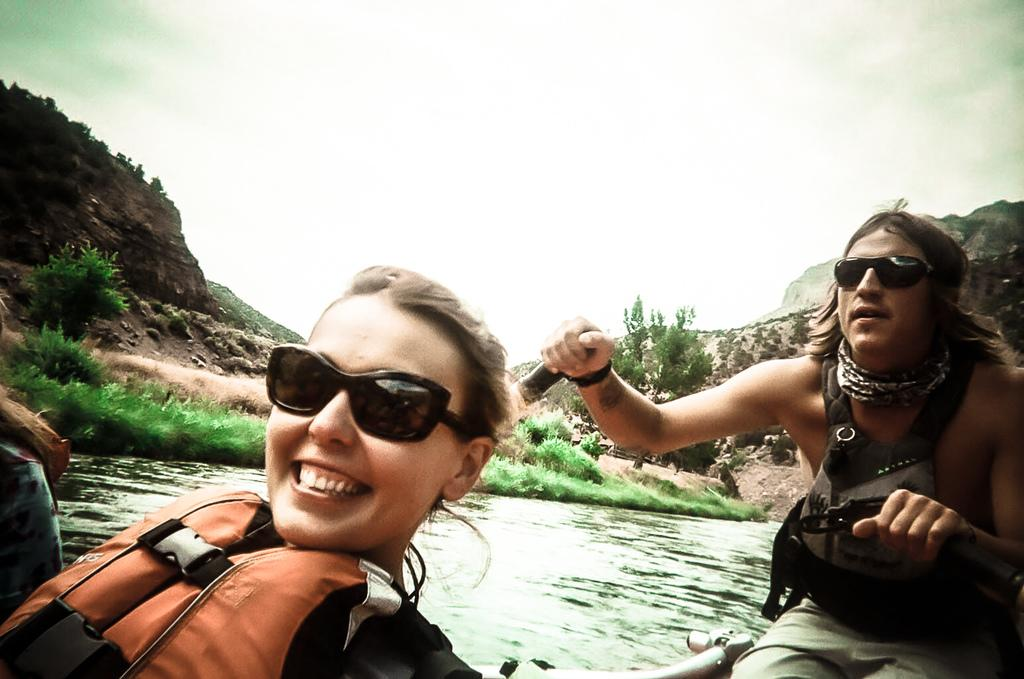How many people are in the image? There are two persons in the image. What is the expression of one of the persons? One of the persons is smiling. What natural elements can be seen in the image? Water, plants, grass, and a mountain are visible in the image. What is visible in the background of the image? The sky and a mountain are visible in the background of the image. How many hands are visible in the image? There is no mention of hands in the provided facts, so we cannot determine the number of hands visible in the image. --- 